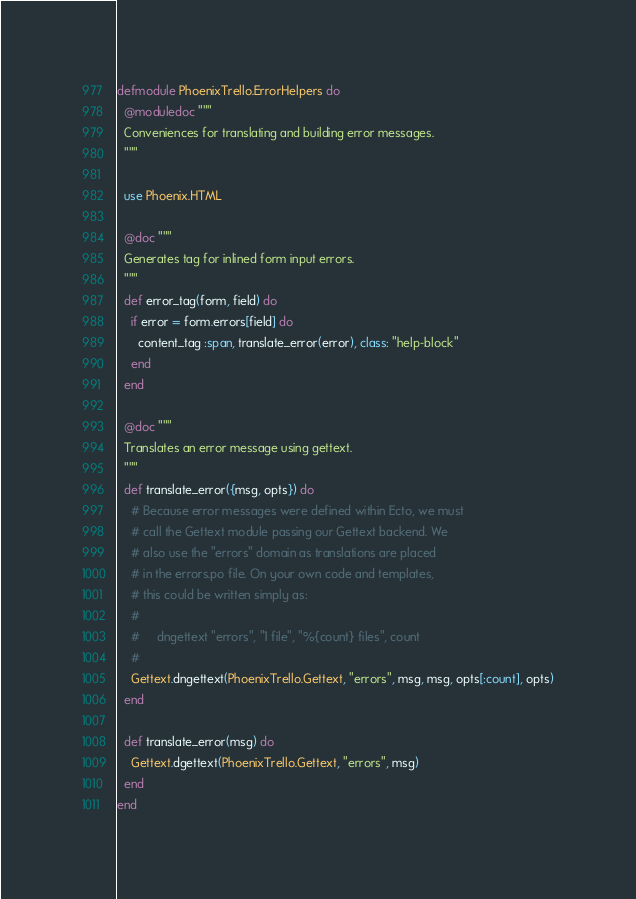Convert code to text. <code><loc_0><loc_0><loc_500><loc_500><_Elixir_>defmodule PhoenixTrello.ErrorHelpers do
  @moduledoc """
  Conveniences for translating and building error messages.
  """

  use Phoenix.HTML

  @doc """
  Generates tag for inlined form input errors.
  """
  def error_tag(form, field) do
    if error = form.errors[field] do
      content_tag :span, translate_error(error), class: "help-block"
    end
  end

  @doc """
  Translates an error message using gettext.
  """
  def translate_error({msg, opts}) do
    # Because error messages were defined within Ecto, we must
    # call the Gettext module passing our Gettext backend. We
    # also use the "errors" domain as translations are placed
    # in the errors.po file. On your own code and templates,
    # this could be written simply as:
    #
    #     dngettext "errors", "1 file", "%{count} files", count
    #
    Gettext.dngettext(PhoenixTrello.Gettext, "errors", msg, msg, opts[:count], opts)
  end

  def translate_error(msg) do
    Gettext.dgettext(PhoenixTrello.Gettext, "errors", msg)
  end
end
</code> 